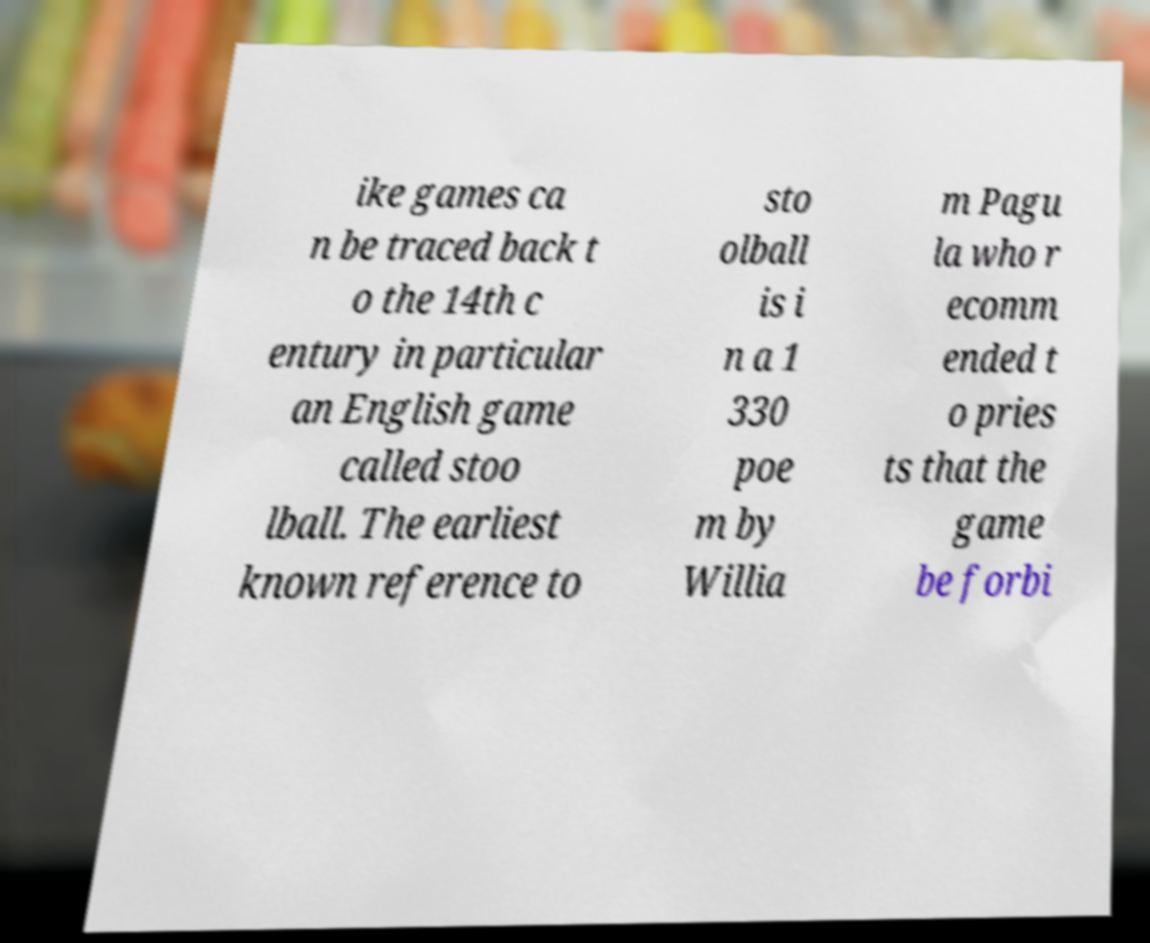What messages or text are displayed in this image? I need them in a readable, typed format. ike games ca n be traced back t o the 14th c entury in particular an English game called stoo lball. The earliest known reference to sto olball is i n a 1 330 poe m by Willia m Pagu la who r ecomm ended t o pries ts that the game be forbi 